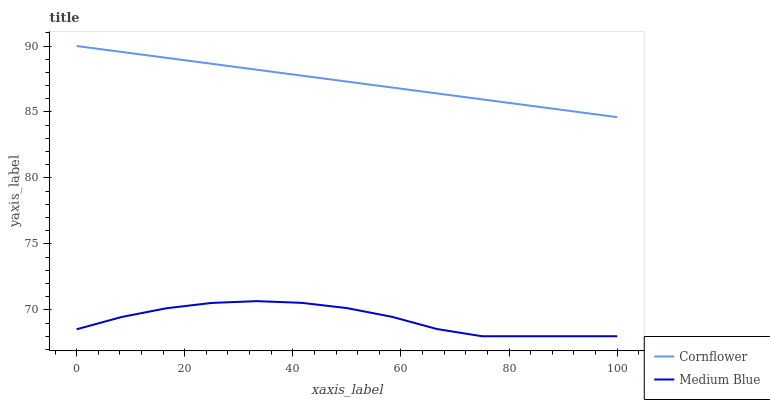Does Medium Blue have the minimum area under the curve?
Answer yes or no. Yes. Does Cornflower have the maximum area under the curve?
Answer yes or no. Yes. Does Medium Blue have the maximum area under the curve?
Answer yes or no. No. Is Cornflower the smoothest?
Answer yes or no. Yes. Is Medium Blue the roughest?
Answer yes or no. Yes. Is Medium Blue the smoothest?
Answer yes or no. No. Does Medium Blue have the lowest value?
Answer yes or no. Yes. Does Cornflower have the highest value?
Answer yes or no. Yes. Does Medium Blue have the highest value?
Answer yes or no. No. Is Medium Blue less than Cornflower?
Answer yes or no. Yes. Is Cornflower greater than Medium Blue?
Answer yes or no. Yes. Does Medium Blue intersect Cornflower?
Answer yes or no. No. 